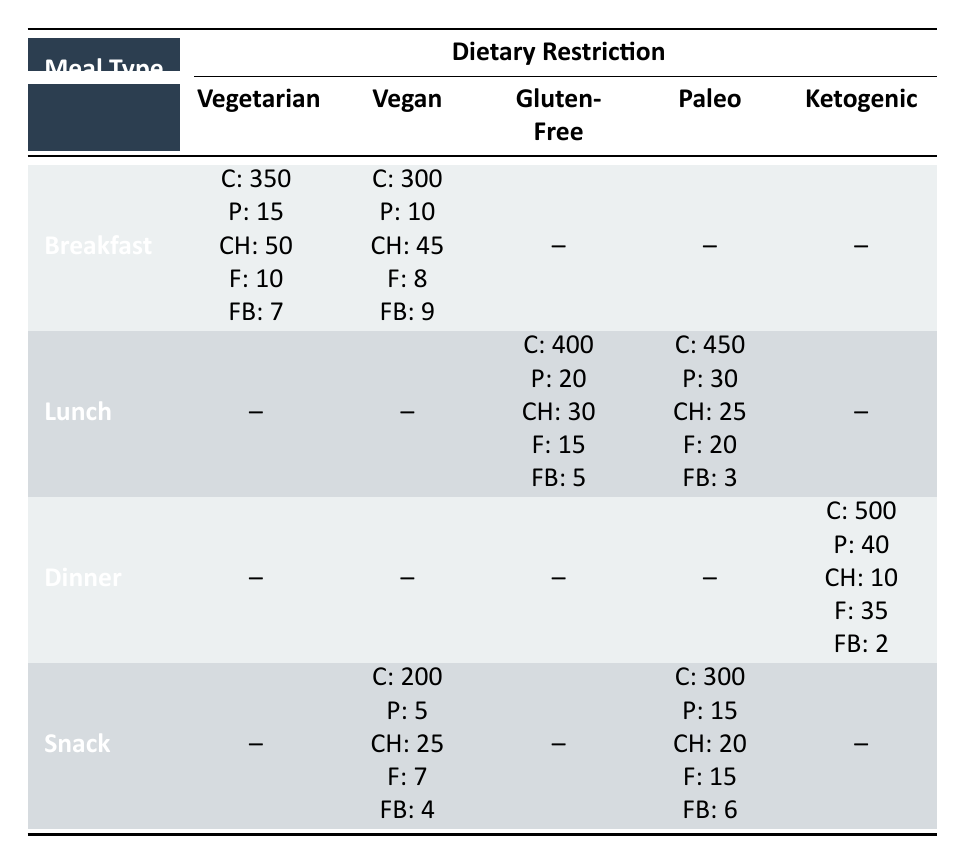What are the protein values for a breakfast meal that is vegetarian? The protein value for a vegetarian breakfast meal is listed directly in the table. It shows "P: 15" under the Breakfast and Vegetarian columns.
Answer: 15 Which meal type has the highest fat content for a snack meal? Two snack meals are listed: Vegan snack with "F: 7" and Paleo snack with "F: 15." The Paleo snack has the higher fat content.
Answer: Snack (Paleo) with 15 Is there a meal type that has no recorded values for the Vegan dietary restriction? By examining the table, there are no entries under Vegan for Lunch and Dinner meals, confirming that both meal types lack recorded values for this dietary restriction.
Answer: Yes What is the average calorie content across all breakfast meals? There are two breakfast meals. Their calorie values are 350 and 300. To find the average: (350 + 300) / 2 = 325.
Answer: 325 Which meal type provides the least fiber under any dietary restriction? The fiber values from all entries are: 7 (Breakfast, Vegetarian), 9 (Breakfast, Vegan), 5 (Lunch, Gluten-Free), 3 (Lunch, Paleo), 2 (Dinner, Ketogenic), 4 (Snack, Vegan), and 6 (Snack, Paleo). The least is 2 for Dinner under Ketogenic.
Answer: Dinner (Ketogenic) with 2 What is the total protein content for all meals that have a gluten-free dietary restriction? There is only one meal with the gluten-free restriction listed in the table, which is Lunch, providing 20 grams of protein. Since there are no other gluten-free meals, the total protein content is simply 20.
Answer: 20 Which meal provides the highest carbohydrates for a lunch meal? Among the two lunch options, the gluten-free meal has 30g of carbohydrates, while the Paleo meal has 25g. Therefore, the gluten-free lunch provides the most carbohydrates.
Answer: Gluten-Free Lunch with 30 Is the vegetarian breakfast meal lower in calories than the vegan breakfast meal? The vegetarian breakfast has 350 calories and the vegan breakfast has 300 calories. Since 350 is greater than 300, the vegetarian breakfast is not lower in calories than the vegan.
Answer: No What is the difference in fat content between the highest and lowest fat snack meals? The highest fat content is in the Paleo snack with 15g and the lowest is in the vegan snack with 7g. The difference is calculated as 15 - 7 = 8 grams.
Answer: 8 grams 